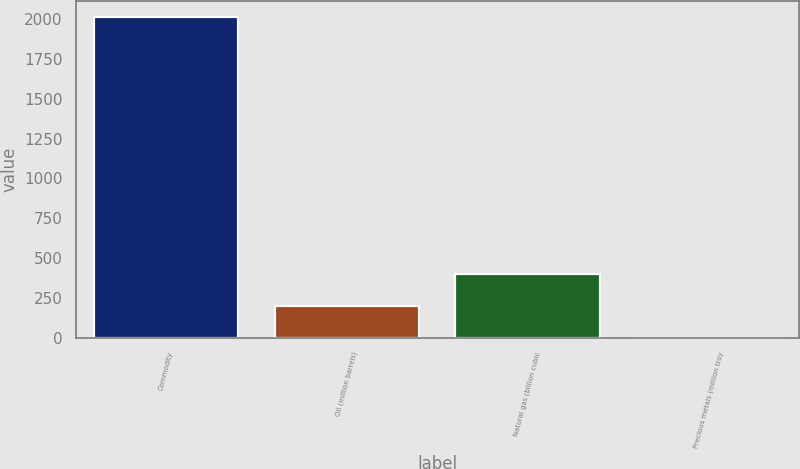<chart> <loc_0><loc_0><loc_500><loc_500><bar_chart><fcel>Commodity<fcel>Oil (million barrels)<fcel>Natural gas (billion cubic<fcel>Precious metals (million troy<nl><fcel>2012<fcel>202.1<fcel>403.2<fcel>1<nl></chart> 